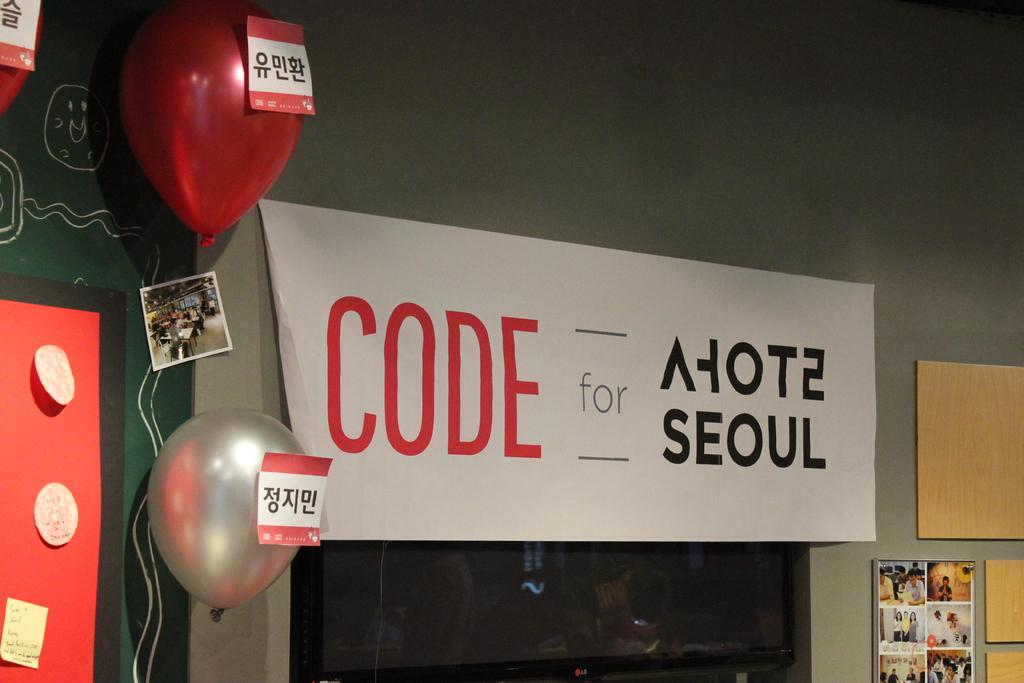What type of decorations are present in the image? There are posters and balloons in the image. What type of structure can be seen in the image? There is a frame in the image. What type of surface is visible in the image? There are boards in the image. What type of display device is present in the image? There is a screen in the image. What is visible in the background of the image? There is a wall in the background of the image. How does the doctor attack the curve in the image? There is no doctor or curve present in the image. 